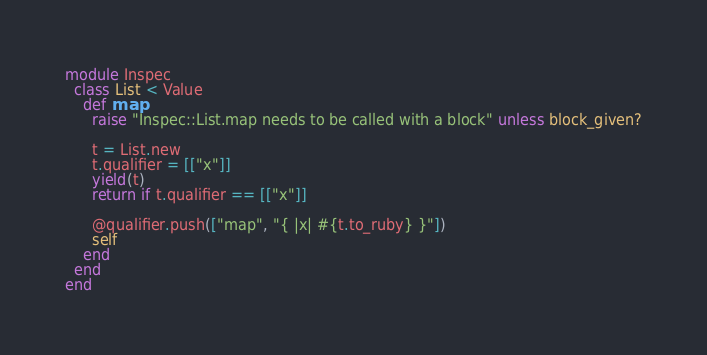Convert code to text. <code><loc_0><loc_0><loc_500><loc_500><_Ruby_>module Inspec
  class List < Value
    def map
      raise "Inspec::List.map needs to be called with a block" unless block_given?

      t = List.new
      t.qualifier = [["x"]]
      yield(t)
      return if t.qualifier == [["x"]]

      @qualifier.push(["map", "{ |x| #{t.to_ruby} }"])
      self
    end
  end
end
</code> 